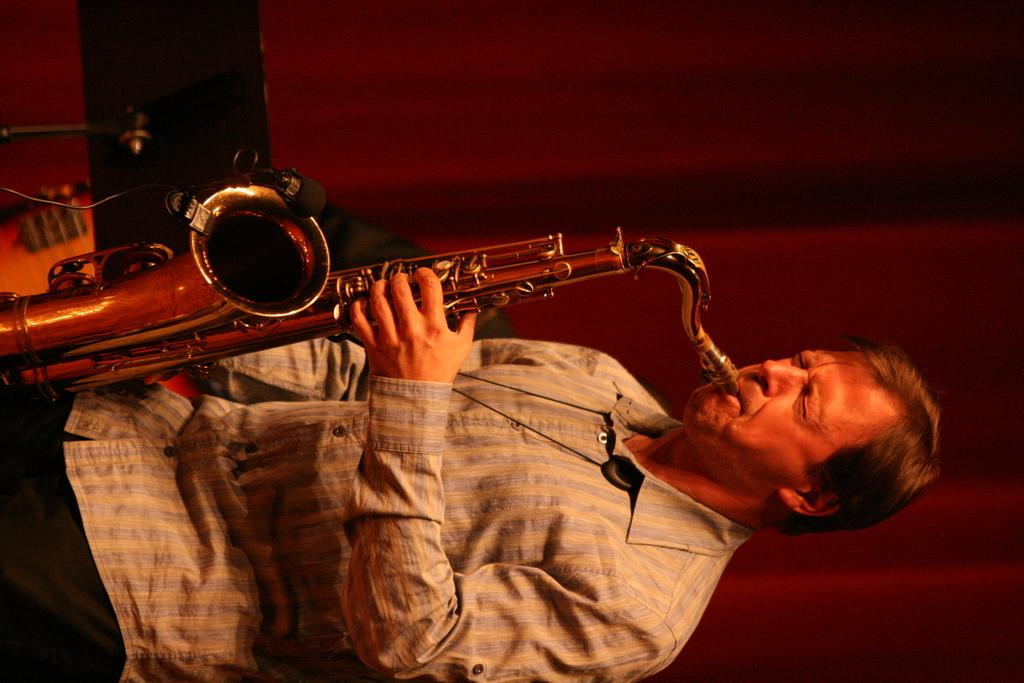What is the main subject of the image? There is a person in the image. What is the person doing in the image? The person is standing and playing a saxophone. Can you describe the background of the image? The background of the image is blurred. How many sisters are visible in the image? There are no sisters present in the image; it features a person playing a saxophone. What type of shoes is the person wearing in the image? The image does not show the person's shoes, so it cannot be determined from the picture. 